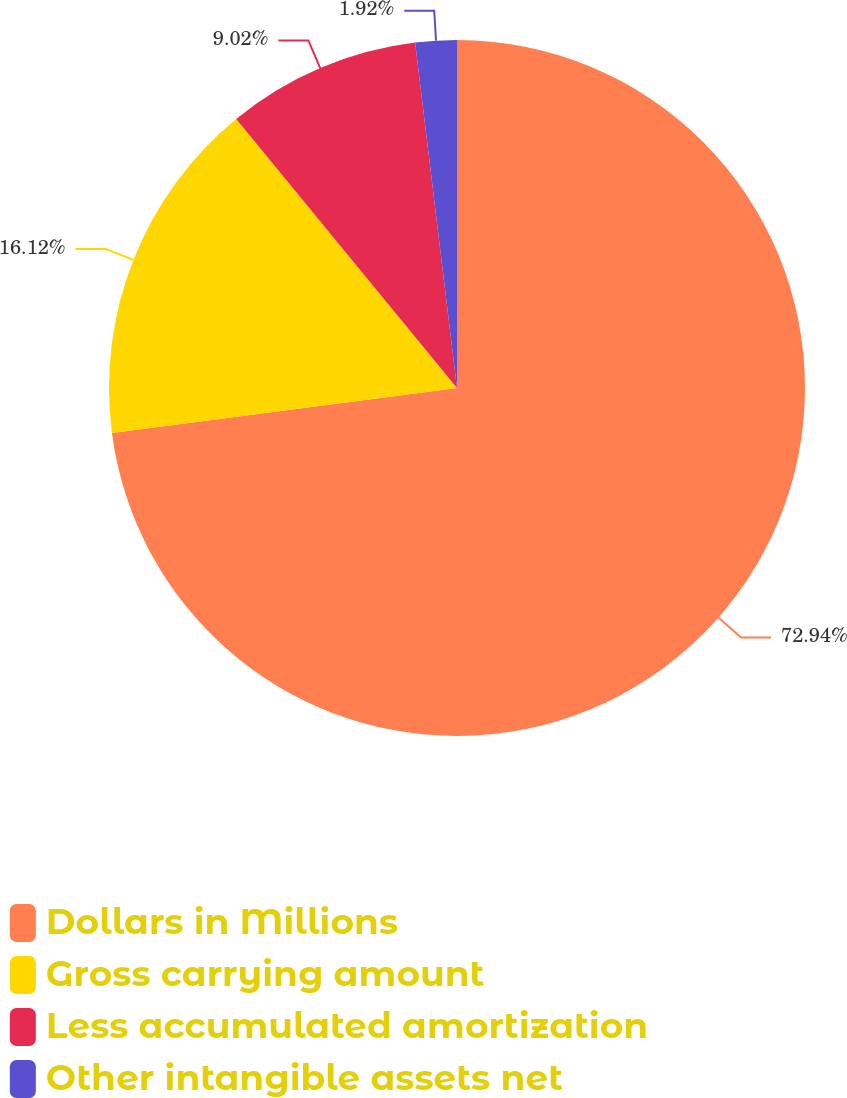Convert chart to OTSL. <chart><loc_0><loc_0><loc_500><loc_500><pie_chart><fcel>Dollars in Millions<fcel>Gross carrying amount<fcel>Less accumulated amortization<fcel>Other intangible assets net<nl><fcel>72.93%<fcel>16.12%<fcel>9.02%<fcel>1.92%<nl></chart> 